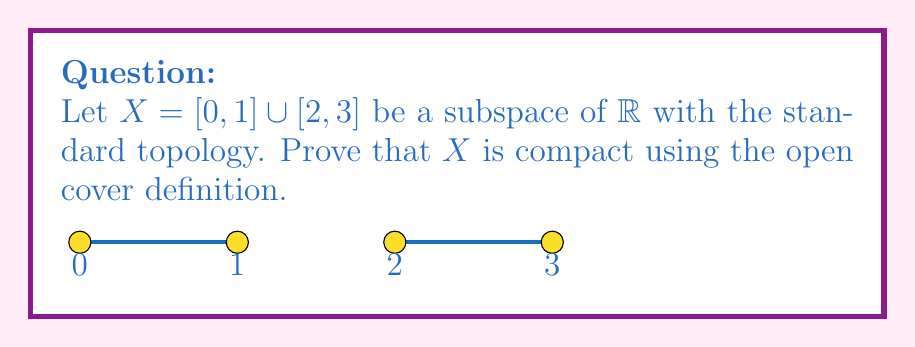Help me with this question. To prove that $X$ is compact, we need to show that every open cover of $X$ has a finite subcover. Let's proceed step by step:

1) Let $\mathcal{U}$ be an arbitrary open cover of $X$.

2) Since $[0,1]$ and $[2,3]$ are closed and bounded intervals in $\mathbb{R}$, they are compact in the standard topology by the Heine-Borel theorem.

3) For $[0,1]$:
   - The collection $\{U \cap [0,1] : U \in \mathcal{U}\}$ forms an open cover of $[0,1]$ in the subspace topology.
   - Since $[0,1]$ is compact, there exists a finite subcover $\{U_1, U_2, ..., U_m\}$ that covers $[0,1]$.

4) For $[2,3]$:
   - Similarly, $\{U \cap [2,3] : U \in \mathcal{U}\}$ forms an open cover of $[2,3]$ in the subspace topology.
   - Since $[2,3]$ is compact, there exists a finite subcover $\{V_1, V_2, ..., V_n\}$ that covers $[2,3]$.

5) The collection $\{U_1, U_2, ..., U_m, V_1, V_2, ..., V_n\}$ is a finite subcover of $\mathcal{U}$ that covers $X$.

6) Since we have found a finite subcover for an arbitrary open cover $\mathcal{U}$, we have proved that $X$ is compact.
Answer: $X$ is compact as every open cover has a finite subcover, constructed from finite subcovers of $[0,1]$ and $[2,3]$. 